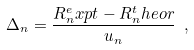<formula> <loc_0><loc_0><loc_500><loc_500>\Delta _ { n } = \frac { R _ { n } ^ { e } x p t - R _ { n } ^ { t } h e o r } { u _ { n } } \ ,</formula> 